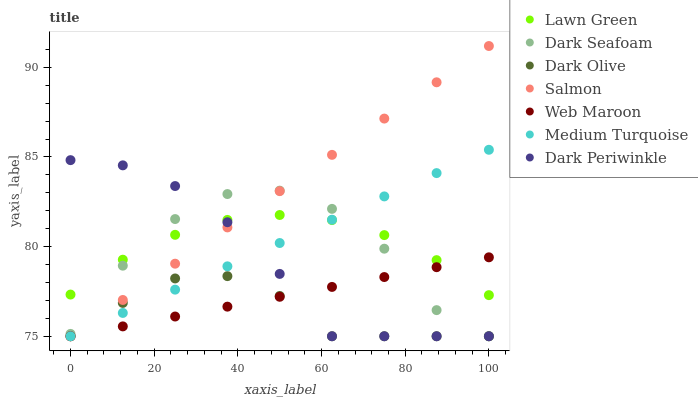Does Dark Olive have the minimum area under the curve?
Answer yes or no. Yes. Does Salmon have the maximum area under the curve?
Answer yes or no. Yes. Does Web Maroon have the minimum area under the curve?
Answer yes or no. No. Does Web Maroon have the maximum area under the curve?
Answer yes or no. No. Is Web Maroon the smoothest?
Answer yes or no. Yes. Is Dark Seafoam the roughest?
Answer yes or no. Yes. Is Dark Olive the smoothest?
Answer yes or no. No. Is Dark Olive the roughest?
Answer yes or no. No. Does Web Maroon have the lowest value?
Answer yes or no. Yes. Does Salmon have the highest value?
Answer yes or no. Yes. Does Web Maroon have the highest value?
Answer yes or no. No. Is Dark Olive less than Lawn Green?
Answer yes or no. Yes. Is Lawn Green greater than Dark Olive?
Answer yes or no. Yes. Does Dark Olive intersect Dark Periwinkle?
Answer yes or no. Yes. Is Dark Olive less than Dark Periwinkle?
Answer yes or no. No. Is Dark Olive greater than Dark Periwinkle?
Answer yes or no. No. Does Dark Olive intersect Lawn Green?
Answer yes or no. No. 